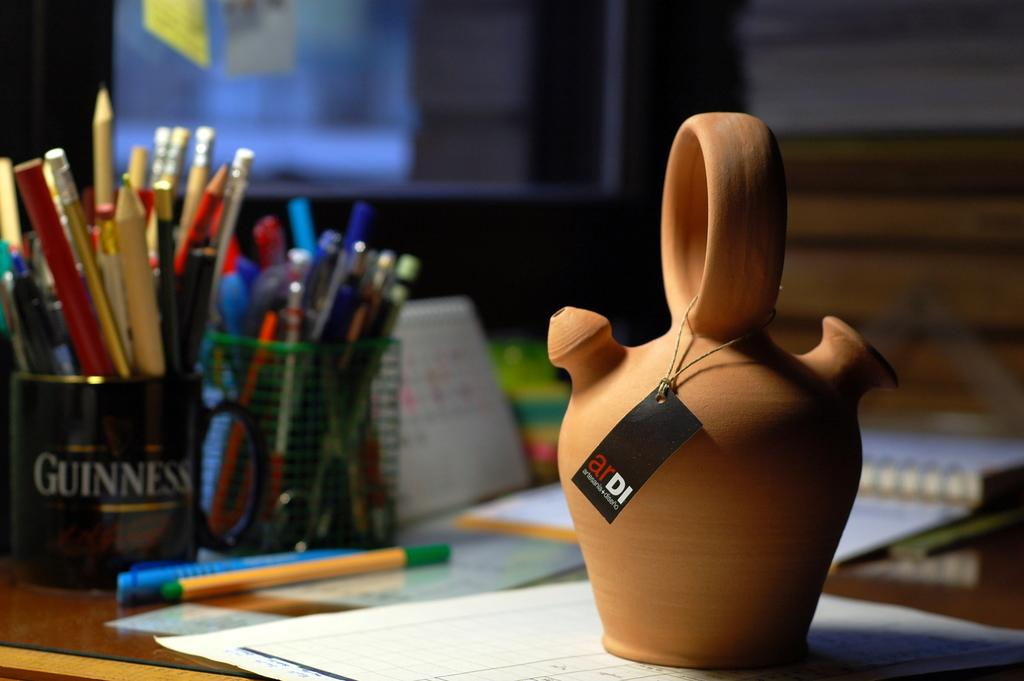Provide a one-sentence caption for the provided image. Guinness cup with pencils and pens on a table with paper. 